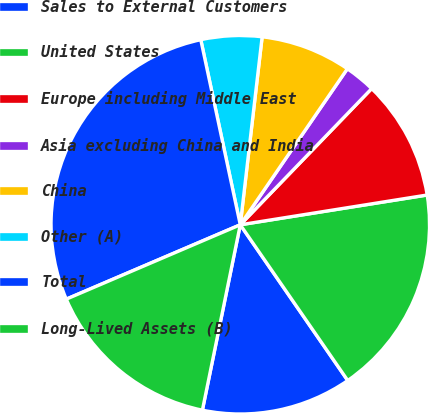Convert chart to OTSL. <chart><loc_0><loc_0><loc_500><loc_500><pie_chart><fcel>Sales to External Customers<fcel>United States<fcel>Europe including Middle East<fcel>Asia excluding China and India<fcel>China<fcel>Other (A)<fcel>Total<fcel>Long-Lived Assets (B)<nl><fcel>12.82%<fcel>17.9%<fcel>10.27%<fcel>2.64%<fcel>7.73%<fcel>5.19%<fcel>28.08%<fcel>15.36%<nl></chart> 